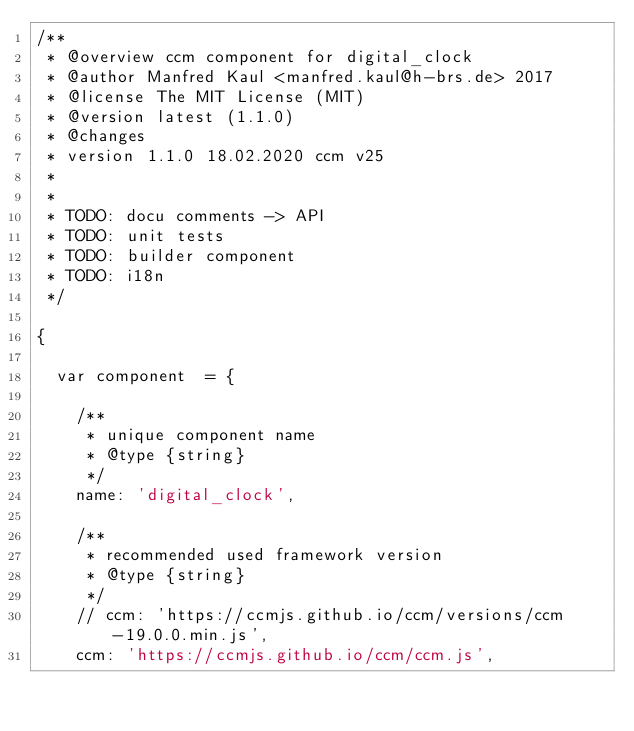Convert code to text. <code><loc_0><loc_0><loc_500><loc_500><_JavaScript_>/**
 * @overview ccm component for digital_clock
 * @author Manfred Kaul <manfred.kaul@h-brs.de> 2017
 * @license The MIT License (MIT)
 * @version latest (1.1.0)
 * @changes
 * version 1.1.0 18.02.2020 ccm v25
 *
 *
 * TODO: docu comments -> API
 * TODO: unit tests
 * TODO: builder component
 * TODO: i18n
 */

{

  var component  = {

    /**
     * unique component name
     * @type {string}
     */
    name: 'digital_clock',
    
    /**
     * recommended used framework version
     * @type {string}
     */
    // ccm: 'https://ccmjs.github.io/ccm/versions/ccm-19.0.0.min.js',
    ccm: 'https://ccmjs.github.io/ccm/ccm.js',</code> 